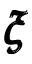<formula> <loc_0><loc_0><loc_500><loc_500>\pm b { \xi }</formula> 